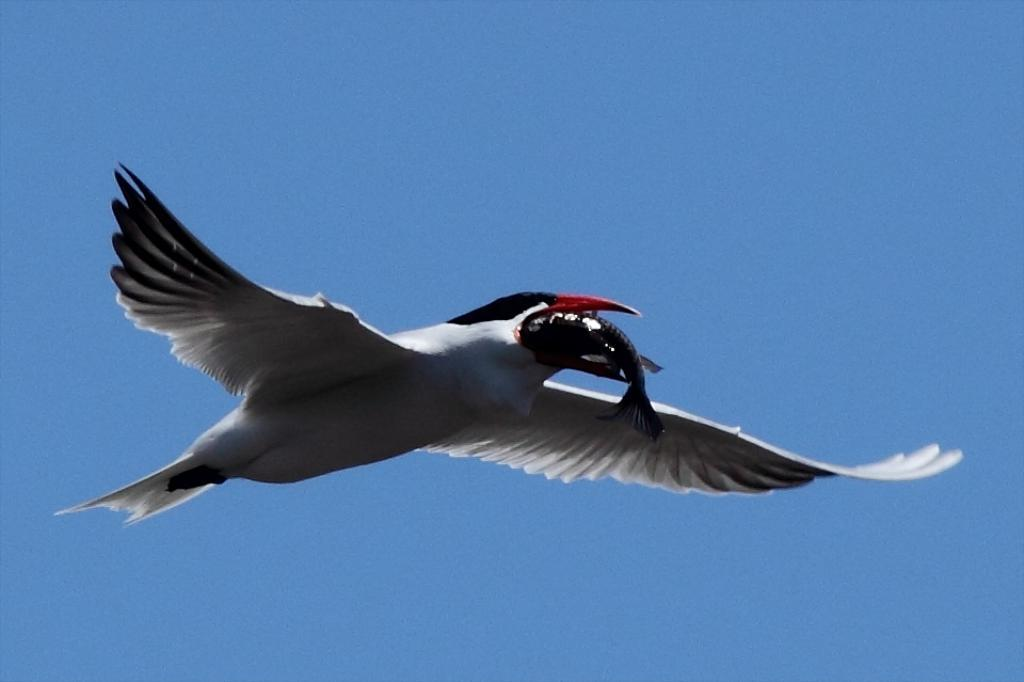What animal can be seen in the image? There is a bird in the image. What is the bird doing in the image? The bird is flying in the air. Can you describe the bird's appearance? The bird has a white and black color. What is the bird holding in its mouth? The bird has a fish in its mouth. What can be seen in the background of the image? There is a sky visible in the background of the image. What type of plants can be seen growing on the mountain in the image? There is no mountain or plants present in the image; it features a bird flying with a fish in its mouth against a sky background. 